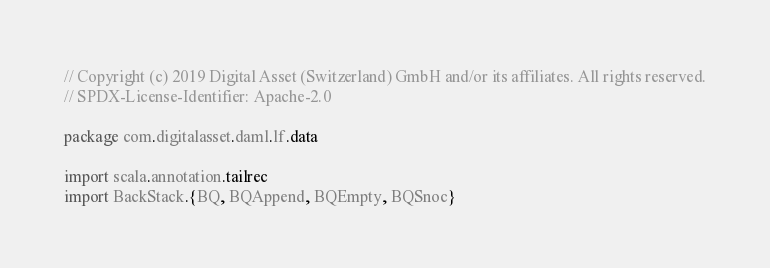<code> <loc_0><loc_0><loc_500><loc_500><_Scala_>// Copyright (c) 2019 Digital Asset (Switzerland) GmbH and/or its affiliates. All rights reserved.
// SPDX-License-Identifier: Apache-2.0

package com.digitalasset.daml.lf.data

import scala.annotation.tailrec
import BackStack.{BQ, BQAppend, BQEmpty, BQSnoc}
</code> 